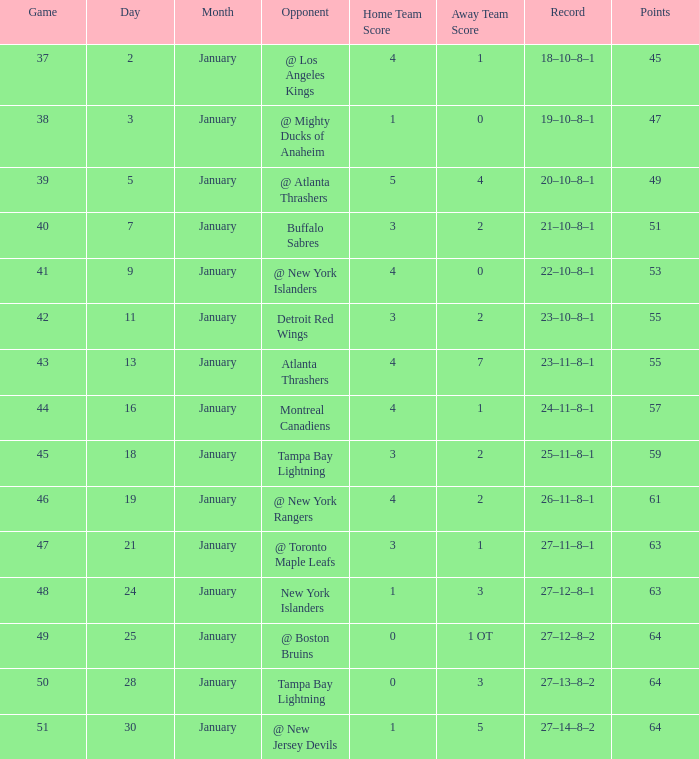Which Points have a Score of 4–1, and a Record of 18–10–8–1, and a January larger than 2? None. 